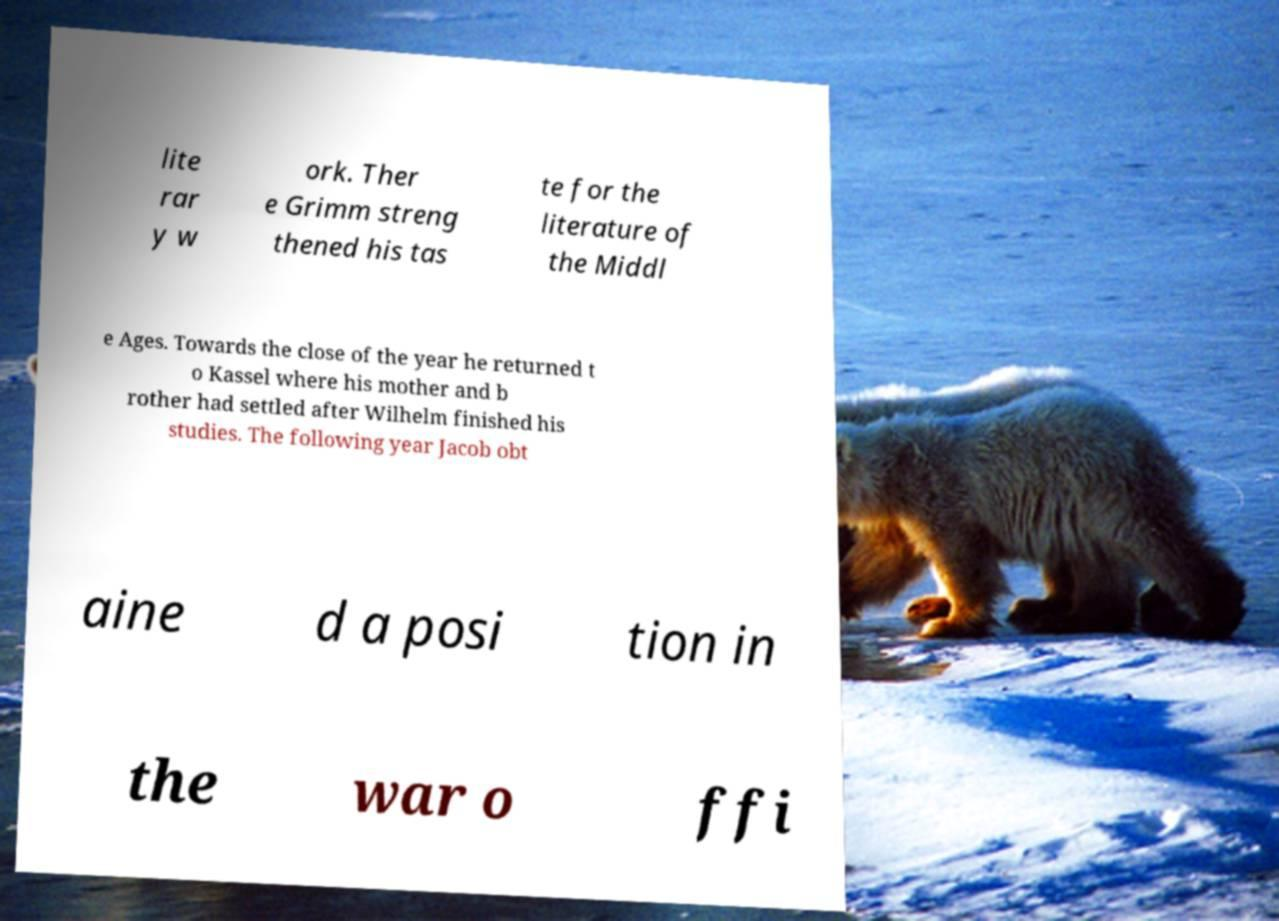Could you assist in decoding the text presented in this image and type it out clearly? lite rar y w ork. Ther e Grimm streng thened his tas te for the literature of the Middl e Ages. Towards the close of the year he returned t o Kassel where his mother and b rother had settled after Wilhelm finished his studies. The following year Jacob obt aine d a posi tion in the war o ffi 